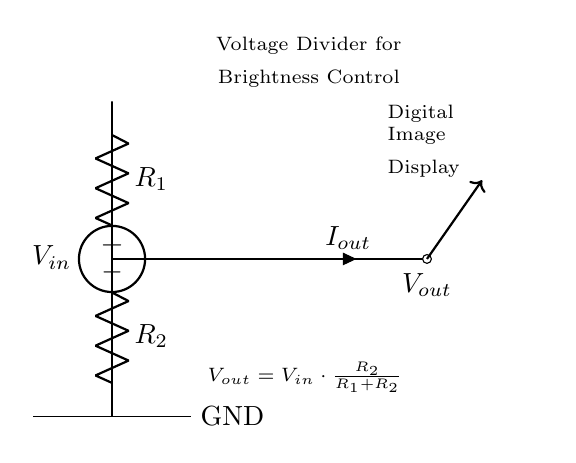What type of circuit is depicted? The circuit is a voltage divider, which is used to split input voltage into smaller output voltages based on the resistor values. This designation is prominently indicated by the arrangement and labeling of the components.
Answer: Voltage Divider What are the two resistors labeled in the circuit? The resistors are labeled R1 and R2, as indicated in the diagram where their values are shown in the series connection between the voltage source and ground.
Answer: R1, R2 What is the formula for Vout? The output voltage formula is derived from the voltage divider rule: Vout = Vin * (R2 / (R1 + R2)). This is explicitly mentioned in the circuit diagram for clarity.
Answer: Vout = Vin * (R2 / (R1 + R2)) How does changing R2 affect Vout? Increasing R2 raises Vout, as the output is directly proportional to R2 in the voltage divider formula. Conversely, decreasing R2 lowers Vout, demonstrating the inverse relationship between R2 and the total resistance R1 + R2.
Answer: Increases Vout What role does Vout play in a digital image display? Vout adjusts the brightness levels of the digital image display; by modifying the output voltage, you can control the level of brightness on the display. This is essential for optimizing visibility and contrast in various lighting conditions.
Answer: Adjusts brightness levels If Vin is 10V and R1 is 1k ohm, what R2 would give Vout of 5V? To find R2, we rearrange the voltage divider formula: R2 = R1 * (Vout / (Vin - Vout)). Substituting the values gives us R2 = 1k * (5 / 5) = 1k ohm. This calculation indicates that a resistor value equal to R1 will achieve the desired output voltage.
Answer: 1k ohm 